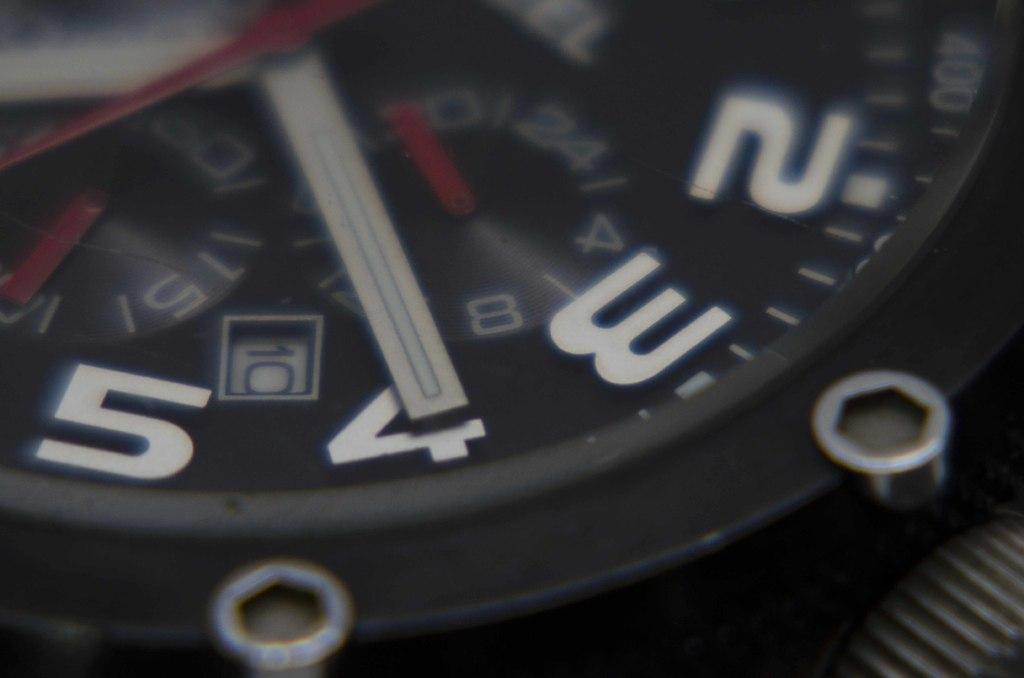<image>
Write a terse but informative summary of the picture. a black watch has the minute hand pointing to the 4 